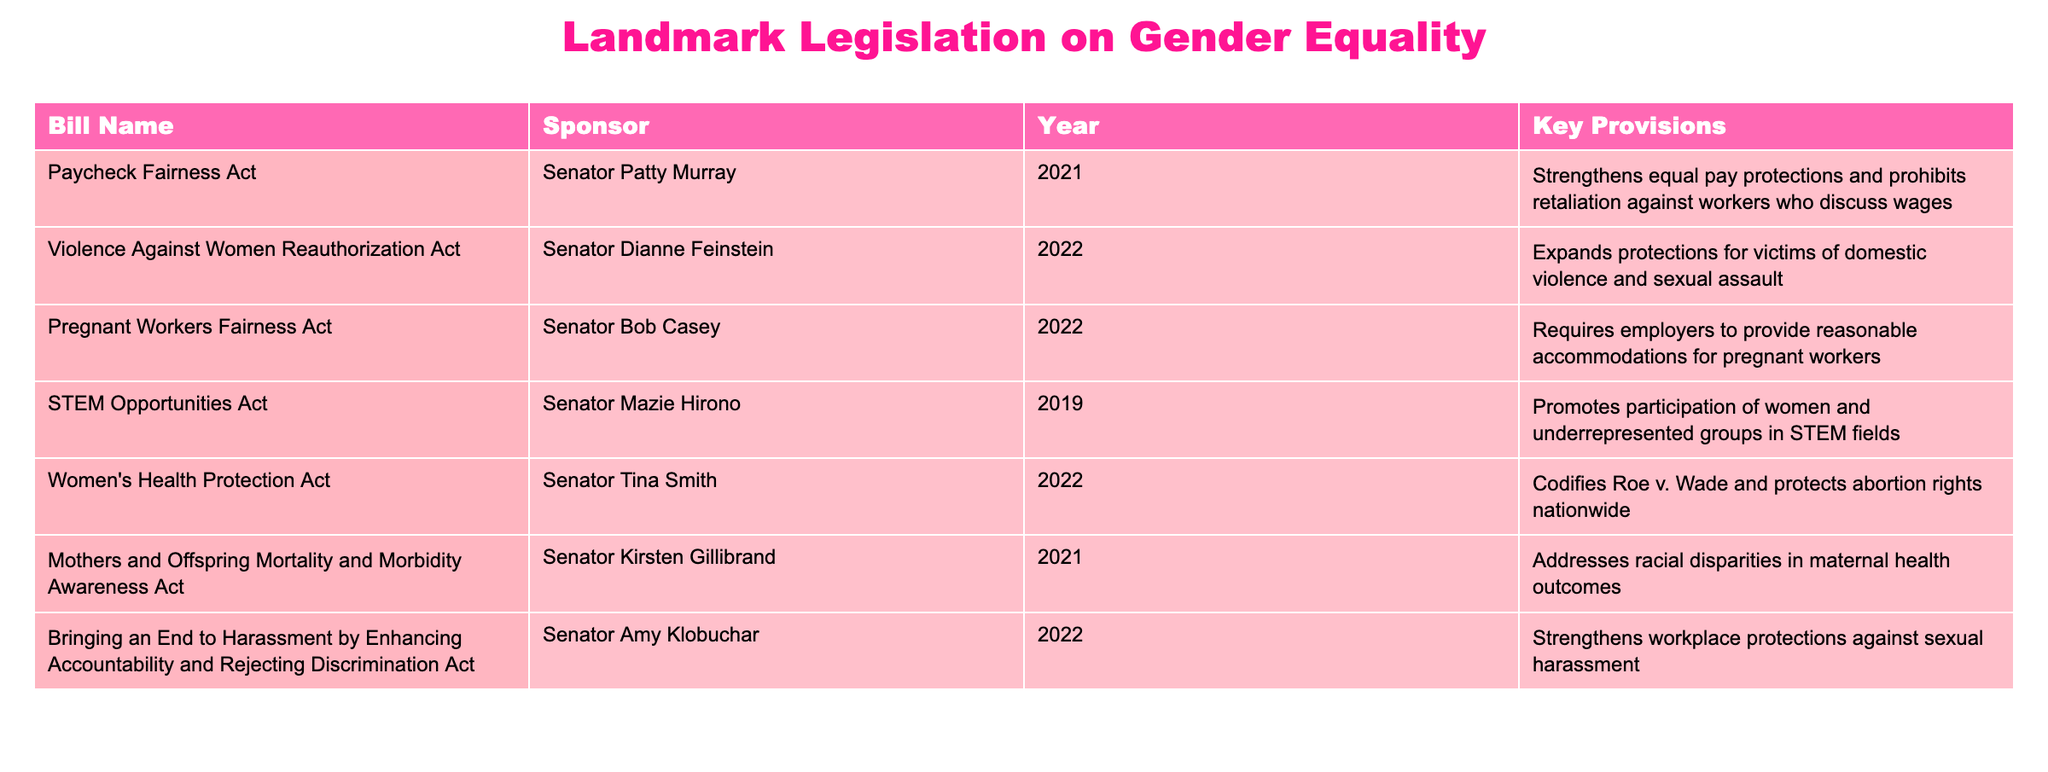What bill did Senator Patty Murray sponsor? According to the table, Senator Patty Murray sponsored the Paycheck Fairness Act in 2021.
Answer: Paycheck Fairness Act In what year was the Violence Against Women Reauthorization Act sponsored? The table indicates that the Violence Against Women Reauthorization Act was sponsored in 2022.
Answer: 2022 How many bills focus specifically on workplace protections? From the table, we can identify two bills that focus on workplace protections: the Paycheck Fairness Act and the Bringing an End to Harassment by Enhancing Accountability and Rejecting Discrimination Act. Thus, there are two such bills.
Answer: 2 What is the key provision of the Women's Health Protection Act? The table states that the Women's Health Protection Act codifies Roe v. Wade and protects abortion rights nationwide.
Answer: Codifies Roe v. Wade and protects abortion rights nationwide Which sponsor's bill addresses racial disparities in maternal health outcomes? The table lists the Mothers and Offspring Mortality and Morbidity Awareness Act sponsored by Senator Kirsten Gillibrand, which specifically addresses racial disparities in maternal health outcomes.
Answer: Senator Kirsten Gillibrand Which bill was sponsored last among the listed legislation? By reviewing the years in the table, the most recent bill listed is the Violence Against Women Reauthorization Act, which was sponsored in 2022.
Answer: Violence Against Women Reauthorization Act Are there any bills related to health? Yes, the table shows two bills related to health: the Women's Health Protection Act and the Mothers and Offspring Mortality and Morbidity Awareness Act.
Answer: Yes What is the total number of senators listed as sponsors for these bills? The table lists seven unique senators as sponsors for the various bills. Thus, the total count of senators is seven.
Answer: 7 What percentage of the bills is focused on issues related to healthcare? Out of the eight bills listed, three are related to healthcare (the Women's Health Protection Act, the Mothers and Offspring Mortality and Morbidity Awareness Act, and the Pregnant Workers Fairness Act). Therefore, the percentage is (3/8) * 100 = 37.5%.
Answer: 37.5% 